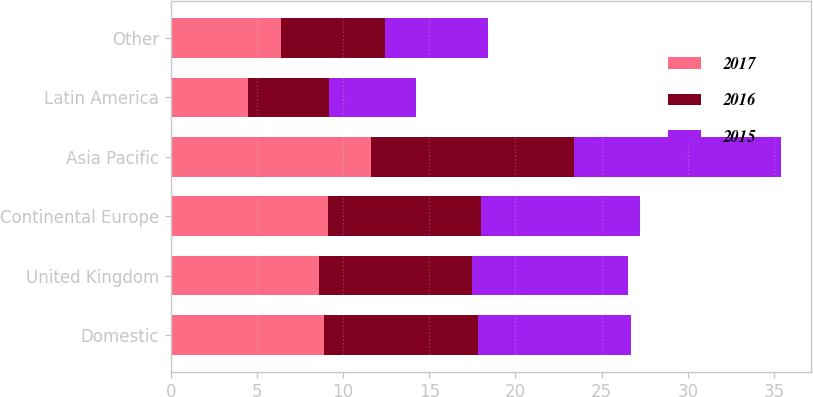<chart> <loc_0><loc_0><loc_500><loc_500><stacked_bar_chart><ecel><fcel>Domestic<fcel>United Kingdom<fcel>Continental Europe<fcel>Asia Pacific<fcel>Latin America<fcel>Other<nl><fcel>2017<fcel>8.9<fcel>8.6<fcel>9.1<fcel>11.6<fcel>4.5<fcel>6.4<nl><fcel>2016<fcel>8.9<fcel>8.9<fcel>8.9<fcel>11.8<fcel>4.7<fcel>6<nl><fcel>2015<fcel>8.9<fcel>9<fcel>9.2<fcel>12<fcel>5<fcel>6<nl></chart> 